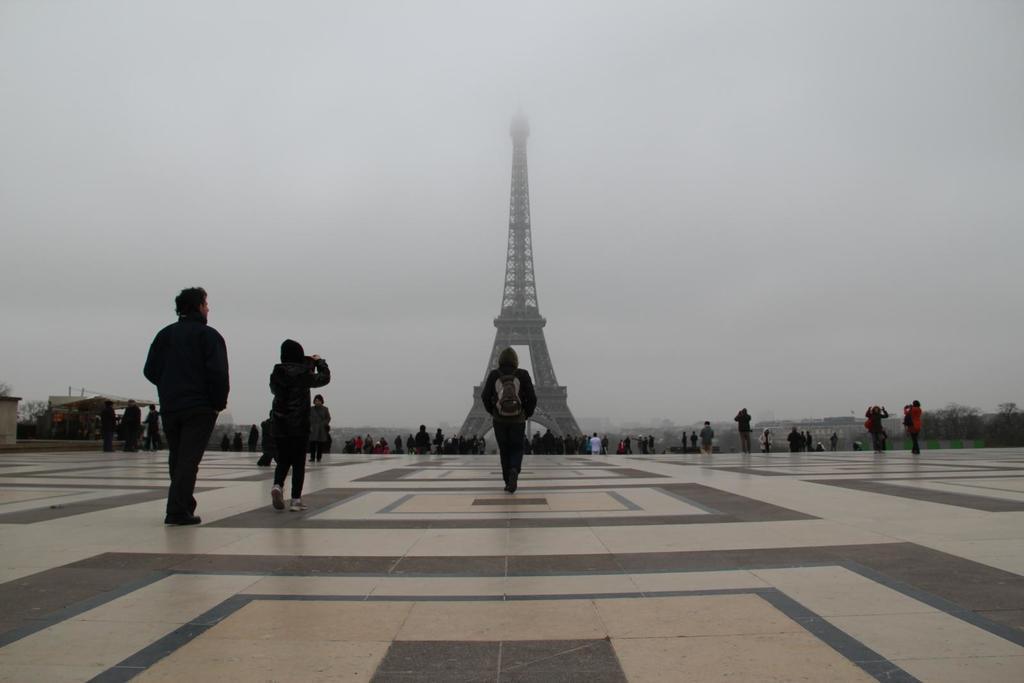In one or two sentences, can you explain what this image depicts? In the foreground of the picture there are people walking on the pavement. In the center of the picture there are trees and many people. In the center of the background it is eiffel tower. Sky is cloudy. 